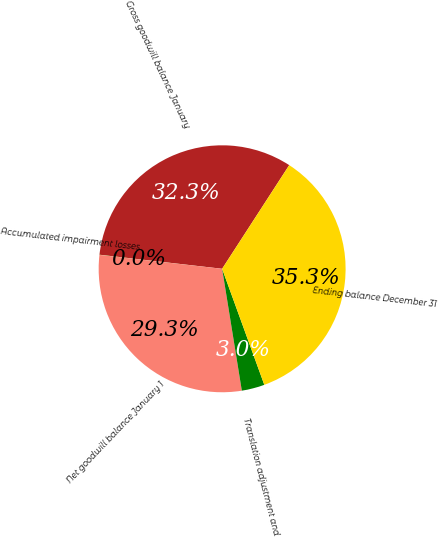Convert chart to OTSL. <chart><loc_0><loc_0><loc_500><loc_500><pie_chart><fcel>Gross goodwill balance January<fcel>Accumulated impairment losses<fcel>Net goodwill balance January 1<fcel>Translation adjustment and<fcel>Ending balance December 31<nl><fcel>32.33%<fcel>0.02%<fcel>29.35%<fcel>3.0%<fcel>35.31%<nl></chart> 